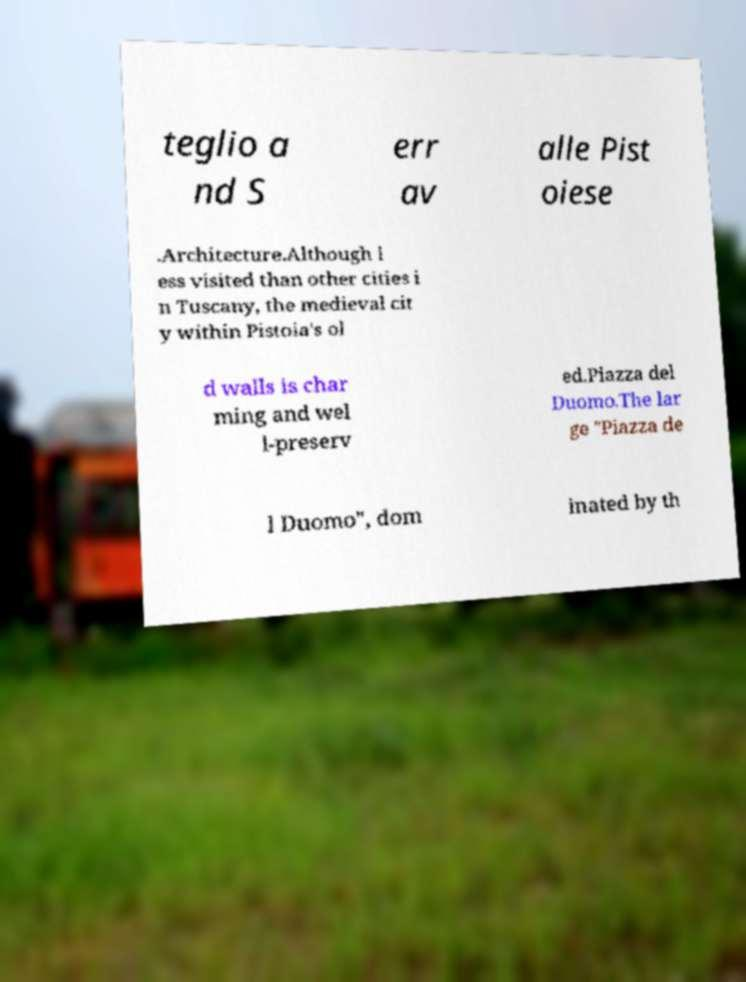Please read and relay the text visible in this image. What does it say? teglio a nd S err av alle Pist oiese .Architecture.Although l ess visited than other cities i n Tuscany, the medieval cit y within Pistoia's ol d walls is char ming and wel l-preserv ed.Piazza del Duomo.The lar ge "Piazza de l Duomo", dom inated by th 